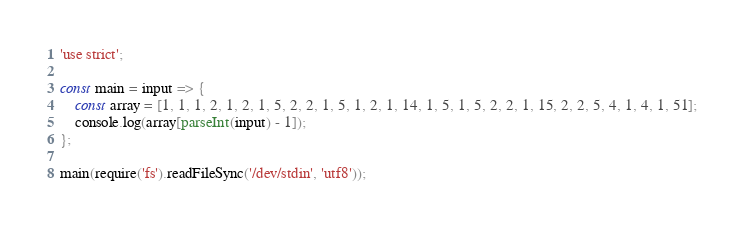<code> <loc_0><loc_0><loc_500><loc_500><_JavaScript_>'use strict';

const main = input => {
    const array = [1, 1, 1, 2, 1, 2, 1, 5, 2, 2, 1, 5, 1, 2, 1, 14, 1, 5, 1, 5, 2, 2, 1, 15, 2, 2, 5, 4, 1, 4, 1, 51];
    console.log(array[parseInt(input) - 1]);
};

main(require('fs').readFileSync('/dev/stdin', 'utf8'));</code> 